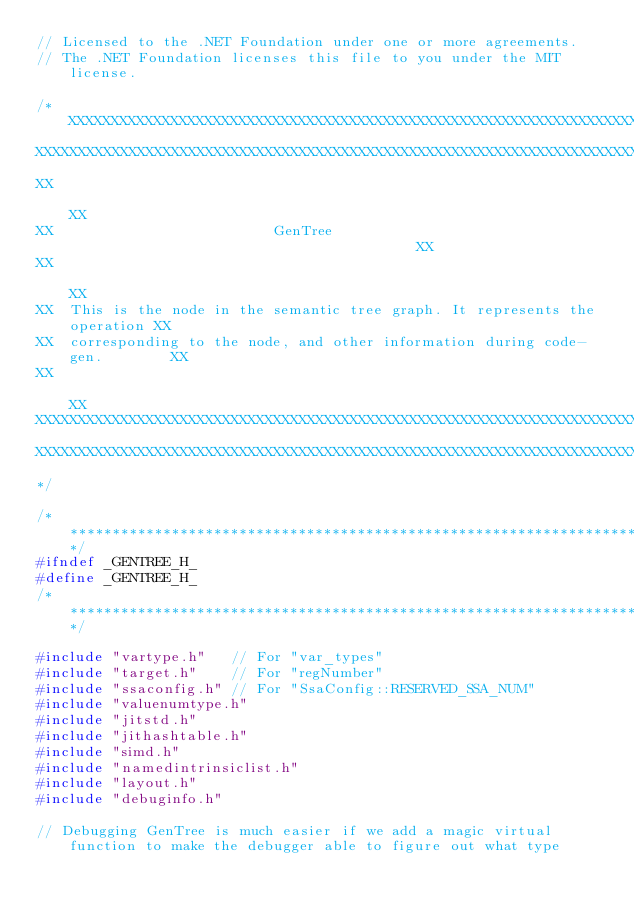Convert code to text. <code><loc_0><loc_0><loc_500><loc_500><_C_>// Licensed to the .NET Foundation under one or more agreements.
// The .NET Foundation licenses this file to you under the MIT license.

/*XXXXXXXXXXXXXXXXXXXXXXXXXXXXXXXXXXXXXXXXXXXXXXXXXXXXXXXXXXXXXXXXXXXXXXXXXXXXX
XXXXXXXXXXXXXXXXXXXXXXXXXXXXXXXXXXXXXXXXXXXXXXXXXXXXXXXXXXXXXXXXXXXXXXXXXXXXXXX
XX                                                                           XX
XX                          GenTree                                          XX
XX                                                                           XX
XX  This is the node in the semantic tree graph. It represents the operation XX
XX  corresponding to the node, and other information during code-gen.        XX
XX                                                                           XX
XXXXXXXXXXXXXXXXXXXXXXXXXXXXXXXXXXXXXXXXXXXXXXXXXXXXXXXXXXXXXXXXXXXXXXXXXXXXXXX
XXXXXXXXXXXXXXXXXXXXXXXXXXXXXXXXXXXXXXXXXXXXXXXXXXXXXXXXXXXXXXXXXXXXXXXXXXXXXXX
*/

/*****************************************************************************/
#ifndef _GENTREE_H_
#define _GENTREE_H_
/*****************************************************************************/

#include "vartype.h"   // For "var_types"
#include "target.h"    // For "regNumber"
#include "ssaconfig.h" // For "SsaConfig::RESERVED_SSA_NUM"
#include "valuenumtype.h"
#include "jitstd.h"
#include "jithashtable.h"
#include "simd.h"
#include "namedintrinsiclist.h"
#include "layout.h"
#include "debuginfo.h"

// Debugging GenTree is much easier if we add a magic virtual function to make the debugger able to figure out what type</code> 